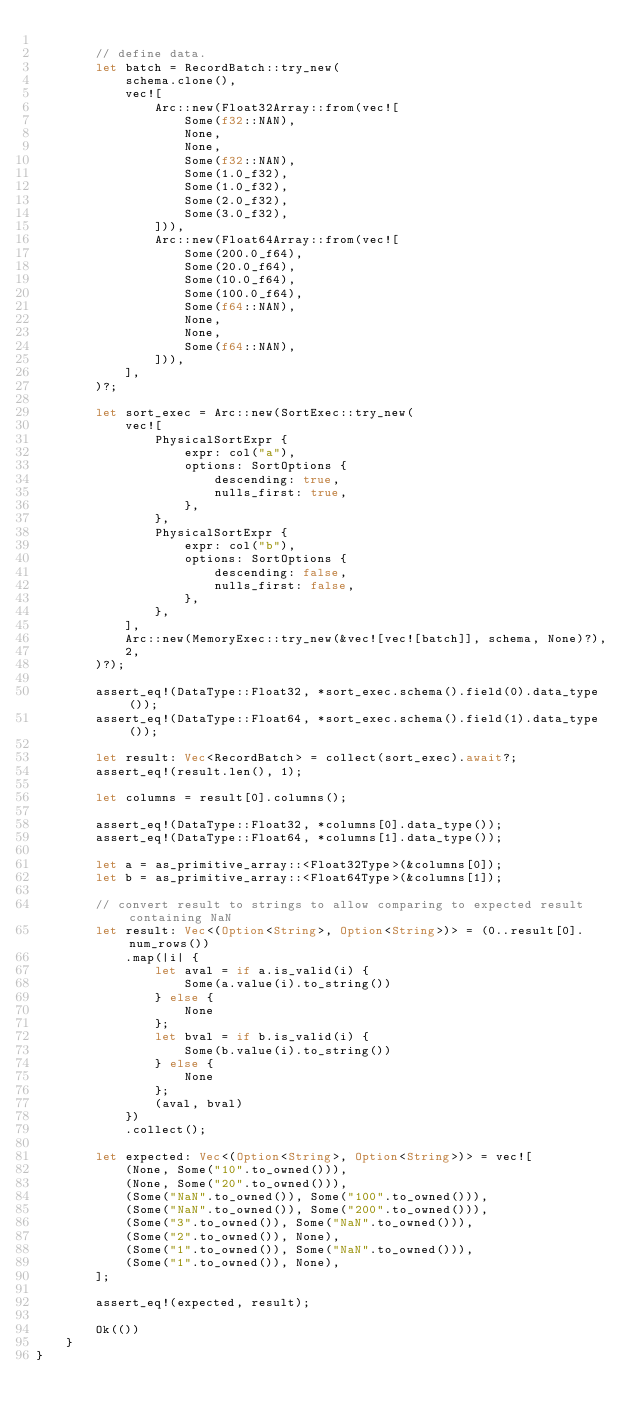<code> <loc_0><loc_0><loc_500><loc_500><_Rust_>
        // define data.
        let batch = RecordBatch::try_new(
            schema.clone(),
            vec![
                Arc::new(Float32Array::from(vec![
                    Some(f32::NAN),
                    None,
                    None,
                    Some(f32::NAN),
                    Some(1.0_f32),
                    Some(1.0_f32),
                    Some(2.0_f32),
                    Some(3.0_f32),
                ])),
                Arc::new(Float64Array::from(vec![
                    Some(200.0_f64),
                    Some(20.0_f64),
                    Some(10.0_f64),
                    Some(100.0_f64),
                    Some(f64::NAN),
                    None,
                    None,
                    Some(f64::NAN),
                ])),
            ],
        )?;

        let sort_exec = Arc::new(SortExec::try_new(
            vec![
                PhysicalSortExpr {
                    expr: col("a"),
                    options: SortOptions {
                        descending: true,
                        nulls_first: true,
                    },
                },
                PhysicalSortExpr {
                    expr: col("b"),
                    options: SortOptions {
                        descending: false,
                        nulls_first: false,
                    },
                },
            ],
            Arc::new(MemoryExec::try_new(&vec![vec![batch]], schema, None)?),
            2,
        )?);

        assert_eq!(DataType::Float32, *sort_exec.schema().field(0).data_type());
        assert_eq!(DataType::Float64, *sort_exec.schema().field(1).data_type());

        let result: Vec<RecordBatch> = collect(sort_exec).await?;
        assert_eq!(result.len(), 1);

        let columns = result[0].columns();

        assert_eq!(DataType::Float32, *columns[0].data_type());
        assert_eq!(DataType::Float64, *columns[1].data_type());

        let a = as_primitive_array::<Float32Type>(&columns[0]);
        let b = as_primitive_array::<Float64Type>(&columns[1]);

        // convert result to strings to allow comparing to expected result containing NaN
        let result: Vec<(Option<String>, Option<String>)> = (0..result[0].num_rows())
            .map(|i| {
                let aval = if a.is_valid(i) {
                    Some(a.value(i).to_string())
                } else {
                    None
                };
                let bval = if b.is_valid(i) {
                    Some(b.value(i).to_string())
                } else {
                    None
                };
                (aval, bval)
            })
            .collect();

        let expected: Vec<(Option<String>, Option<String>)> = vec![
            (None, Some("10".to_owned())),
            (None, Some("20".to_owned())),
            (Some("NaN".to_owned()), Some("100".to_owned())),
            (Some("NaN".to_owned()), Some("200".to_owned())),
            (Some("3".to_owned()), Some("NaN".to_owned())),
            (Some("2".to_owned()), None),
            (Some("1".to_owned()), Some("NaN".to_owned())),
            (Some("1".to_owned()), None),
        ];

        assert_eq!(expected, result);

        Ok(())
    }
}
</code> 